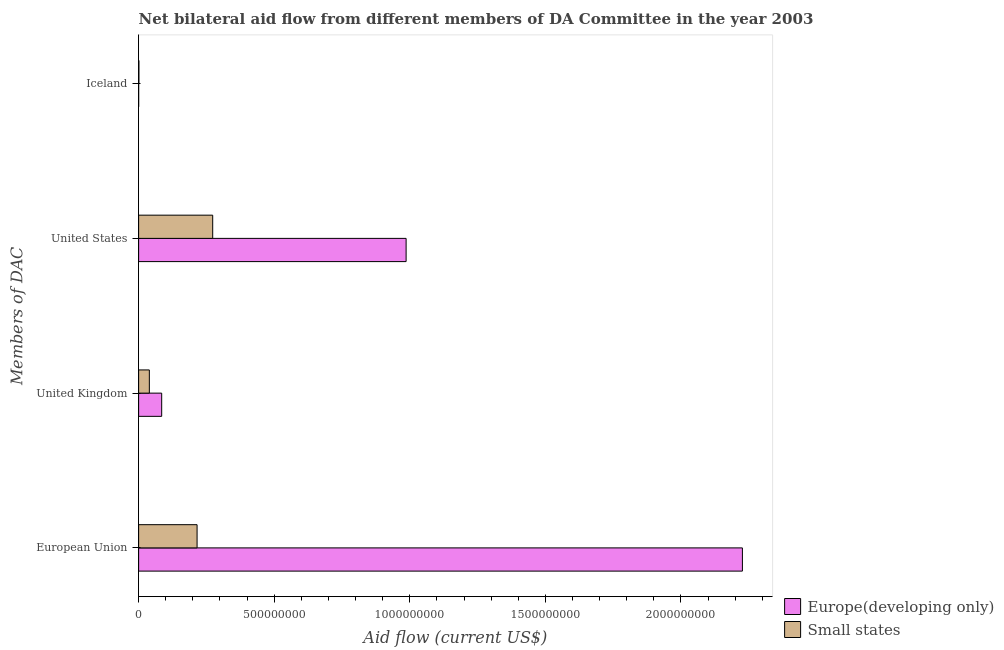How many different coloured bars are there?
Your answer should be very brief. 2. Are the number of bars on each tick of the Y-axis equal?
Your answer should be very brief. Yes. How many bars are there on the 2nd tick from the top?
Your answer should be compact. 2. How many bars are there on the 1st tick from the bottom?
Your answer should be compact. 2. What is the amount of aid given by us in Europe(developing only)?
Your response must be concise. 9.86e+08. Across all countries, what is the maximum amount of aid given by us?
Provide a succinct answer. 9.86e+08. Across all countries, what is the minimum amount of aid given by uk?
Offer a very short reply. 3.95e+07. In which country was the amount of aid given by us maximum?
Your answer should be compact. Europe(developing only). In which country was the amount of aid given by iceland minimum?
Make the answer very short. Europe(developing only). What is the total amount of aid given by iceland in the graph?
Provide a short and direct response. 1.06e+06. What is the difference between the amount of aid given by iceland in Small states and that in Europe(developing only)?
Your answer should be very brief. 9.40e+05. What is the difference between the amount of aid given by iceland in Small states and the amount of aid given by eu in Europe(developing only)?
Your response must be concise. -2.23e+09. What is the average amount of aid given by iceland per country?
Offer a very short reply. 5.30e+05. What is the difference between the amount of aid given by eu and amount of aid given by uk in Europe(developing only)?
Ensure brevity in your answer.  2.14e+09. What is the ratio of the amount of aid given by uk in Small states to that in Europe(developing only)?
Provide a short and direct response. 0.46. Is the difference between the amount of aid given by uk in Small states and Europe(developing only) greater than the difference between the amount of aid given by iceland in Small states and Europe(developing only)?
Your answer should be compact. No. What is the difference between the highest and the second highest amount of aid given by iceland?
Make the answer very short. 9.40e+05. What is the difference between the highest and the lowest amount of aid given by uk?
Your answer should be compact. 4.56e+07. In how many countries, is the amount of aid given by us greater than the average amount of aid given by us taken over all countries?
Offer a terse response. 1. Is the sum of the amount of aid given by iceland in Small states and Europe(developing only) greater than the maximum amount of aid given by eu across all countries?
Your answer should be very brief. No. Is it the case that in every country, the sum of the amount of aid given by iceland and amount of aid given by us is greater than the sum of amount of aid given by eu and amount of aid given by uk?
Make the answer very short. Yes. What does the 1st bar from the top in United Kingdom represents?
Ensure brevity in your answer.  Small states. What does the 1st bar from the bottom in United States represents?
Offer a very short reply. Europe(developing only). Are all the bars in the graph horizontal?
Give a very brief answer. Yes. What is the difference between two consecutive major ticks on the X-axis?
Offer a very short reply. 5.00e+08. Does the graph contain grids?
Keep it short and to the point. No. How many legend labels are there?
Your answer should be very brief. 2. What is the title of the graph?
Provide a succinct answer. Net bilateral aid flow from different members of DA Committee in the year 2003. Does "Lao PDR" appear as one of the legend labels in the graph?
Provide a short and direct response. No. What is the label or title of the Y-axis?
Your answer should be very brief. Members of DAC. What is the Aid flow (current US$) in Europe(developing only) in European Union?
Give a very brief answer. 2.23e+09. What is the Aid flow (current US$) in Small states in European Union?
Your answer should be compact. 2.16e+08. What is the Aid flow (current US$) of Europe(developing only) in United Kingdom?
Offer a terse response. 8.50e+07. What is the Aid flow (current US$) in Small states in United Kingdom?
Provide a short and direct response. 3.95e+07. What is the Aid flow (current US$) of Europe(developing only) in United States?
Your response must be concise. 9.86e+08. What is the Aid flow (current US$) in Small states in United States?
Your answer should be very brief. 2.73e+08. What is the Aid flow (current US$) in Europe(developing only) in Iceland?
Your response must be concise. 6.00e+04. What is the Aid flow (current US$) of Small states in Iceland?
Provide a succinct answer. 1.00e+06. Across all Members of DAC, what is the maximum Aid flow (current US$) in Europe(developing only)?
Give a very brief answer. 2.23e+09. Across all Members of DAC, what is the maximum Aid flow (current US$) of Small states?
Your answer should be compact. 2.73e+08. Across all Members of DAC, what is the minimum Aid flow (current US$) in Europe(developing only)?
Give a very brief answer. 6.00e+04. Across all Members of DAC, what is the minimum Aid flow (current US$) of Small states?
Offer a very short reply. 1.00e+06. What is the total Aid flow (current US$) of Europe(developing only) in the graph?
Ensure brevity in your answer.  3.30e+09. What is the total Aid flow (current US$) of Small states in the graph?
Your response must be concise. 5.29e+08. What is the difference between the Aid flow (current US$) of Europe(developing only) in European Union and that in United Kingdom?
Provide a succinct answer. 2.14e+09. What is the difference between the Aid flow (current US$) of Small states in European Union and that in United Kingdom?
Ensure brevity in your answer.  1.76e+08. What is the difference between the Aid flow (current US$) in Europe(developing only) in European Union and that in United States?
Your answer should be very brief. 1.24e+09. What is the difference between the Aid flow (current US$) of Small states in European Union and that in United States?
Offer a terse response. -5.76e+07. What is the difference between the Aid flow (current US$) in Europe(developing only) in European Union and that in Iceland?
Offer a very short reply. 2.23e+09. What is the difference between the Aid flow (current US$) of Small states in European Union and that in Iceland?
Provide a succinct answer. 2.15e+08. What is the difference between the Aid flow (current US$) of Europe(developing only) in United Kingdom and that in United States?
Offer a terse response. -9.01e+08. What is the difference between the Aid flow (current US$) in Small states in United Kingdom and that in United States?
Your answer should be very brief. -2.34e+08. What is the difference between the Aid flow (current US$) in Europe(developing only) in United Kingdom and that in Iceland?
Your answer should be very brief. 8.50e+07. What is the difference between the Aid flow (current US$) of Small states in United Kingdom and that in Iceland?
Your response must be concise. 3.85e+07. What is the difference between the Aid flow (current US$) of Europe(developing only) in United States and that in Iceland?
Offer a very short reply. 9.86e+08. What is the difference between the Aid flow (current US$) in Small states in United States and that in Iceland?
Make the answer very short. 2.72e+08. What is the difference between the Aid flow (current US$) in Europe(developing only) in European Union and the Aid flow (current US$) in Small states in United Kingdom?
Provide a succinct answer. 2.19e+09. What is the difference between the Aid flow (current US$) of Europe(developing only) in European Union and the Aid flow (current US$) of Small states in United States?
Make the answer very short. 1.95e+09. What is the difference between the Aid flow (current US$) of Europe(developing only) in European Union and the Aid flow (current US$) of Small states in Iceland?
Your response must be concise. 2.23e+09. What is the difference between the Aid flow (current US$) in Europe(developing only) in United Kingdom and the Aid flow (current US$) in Small states in United States?
Make the answer very short. -1.88e+08. What is the difference between the Aid flow (current US$) in Europe(developing only) in United Kingdom and the Aid flow (current US$) in Small states in Iceland?
Your answer should be compact. 8.40e+07. What is the difference between the Aid flow (current US$) in Europe(developing only) in United States and the Aid flow (current US$) in Small states in Iceland?
Your answer should be very brief. 9.86e+08. What is the average Aid flow (current US$) in Europe(developing only) per Members of DAC?
Your answer should be compact. 8.25e+08. What is the average Aid flow (current US$) in Small states per Members of DAC?
Provide a succinct answer. 1.32e+08. What is the difference between the Aid flow (current US$) in Europe(developing only) and Aid flow (current US$) in Small states in European Union?
Your response must be concise. 2.01e+09. What is the difference between the Aid flow (current US$) in Europe(developing only) and Aid flow (current US$) in Small states in United Kingdom?
Ensure brevity in your answer.  4.56e+07. What is the difference between the Aid flow (current US$) in Europe(developing only) and Aid flow (current US$) in Small states in United States?
Keep it short and to the point. 7.13e+08. What is the difference between the Aid flow (current US$) in Europe(developing only) and Aid flow (current US$) in Small states in Iceland?
Your response must be concise. -9.40e+05. What is the ratio of the Aid flow (current US$) of Europe(developing only) in European Union to that in United Kingdom?
Offer a terse response. 26.19. What is the ratio of the Aid flow (current US$) of Small states in European Union to that in United Kingdom?
Offer a very short reply. 5.46. What is the ratio of the Aid flow (current US$) in Europe(developing only) in European Union to that in United States?
Offer a very short reply. 2.26. What is the ratio of the Aid flow (current US$) of Small states in European Union to that in United States?
Provide a short and direct response. 0.79. What is the ratio of the Aid flow (current US$) in Europe(developing only) in European Union to that in Iceland?
Provide a succinct answer. 3.71e+04. What is the ratio of the Aid flow (current US$) of Small states in European Union to that in Iceland?
Offer a very short reply. 215.56. What is the ratio of the Aid flow (current US$) of Europe(developing only) in United Kingdom to that in United States?
Your answer should be very brief. 0.09. What is the ratio of the Aid flow (current US$) of Small states in United Kingdom to that in United States?
Give a very brief answer. 0.14. What is the ratio of the Aid flow (current US$) of Europe(developing only) in United Kingdom to that in Iceland?
Ensure brevity in your answer.  1417.33. What is the ratio of the Aid flow (current US$) in Small states in United Kingdom to that in Iceland?
Provide a short and direct response. 39.49. What is the ratio of the Aid flow (current US$) of Europe(developing only) in United States to that in Iceland?
Your answer should be compact. 1.64e+04. What is the ratio of the Aid flow (current US$) of Small states in United States to that in Iceland?
Provide a succinct answer. 273.18. What is the difference between the highest and the second highest Aid flow (current US$) of Europe(developing only)?
Keep it short and to the point. 1.24e+09. What is the difference between the highest and the second highest Aid flow (current US$) of Small states?
Make the answer very short. 5.76e+07. What is the difference between the highest and the lowest Aid flow (current US$) in Europe(developing only)?
Offer a very short reply. 2.23e+09. What is the difference between the highest and the lowest Aid flow (current US$) of Small states?
Your response must be concise. 2.72e+08. 